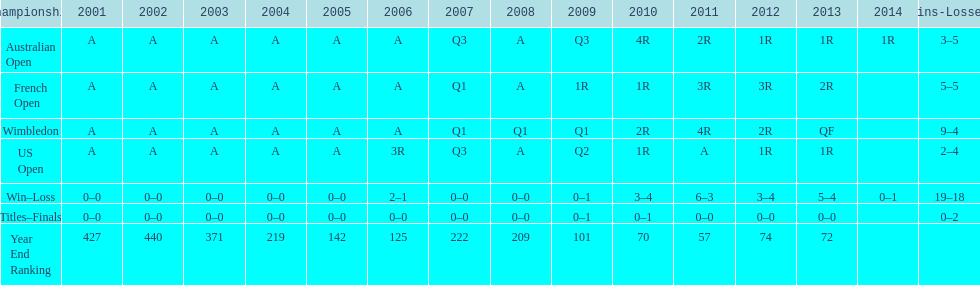What was this players ranking after 2005? 125. 